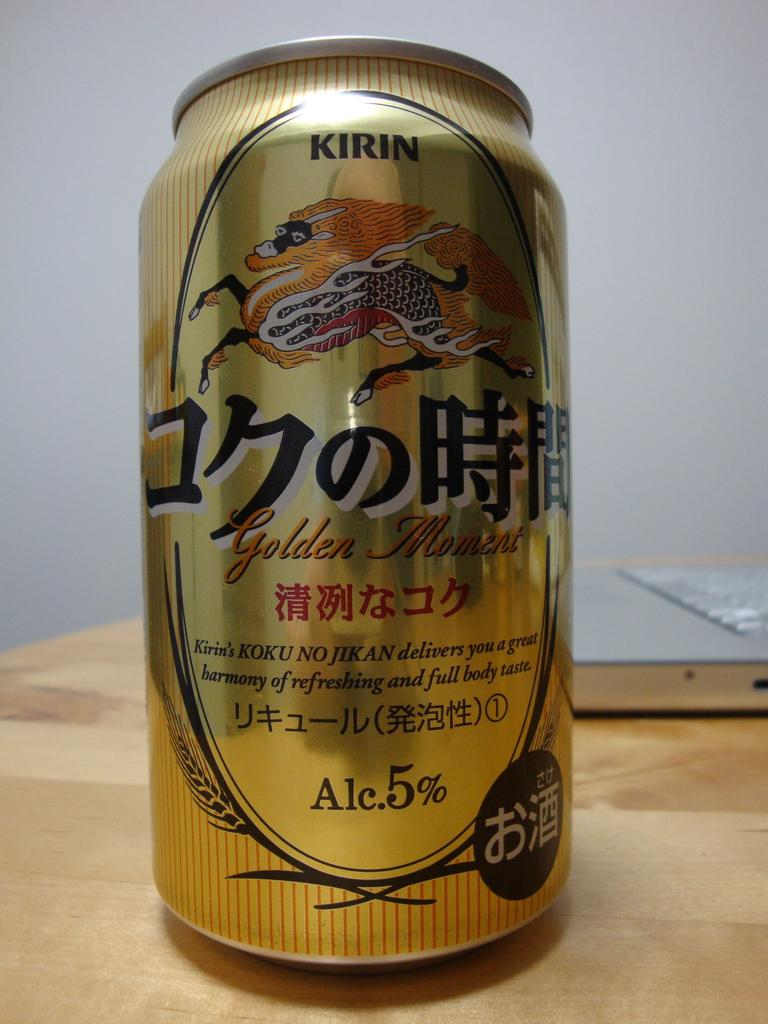<image>
Share a concise interpretation of the image provided. Can of beer that shows a dragon and says alcohol is 5%. 